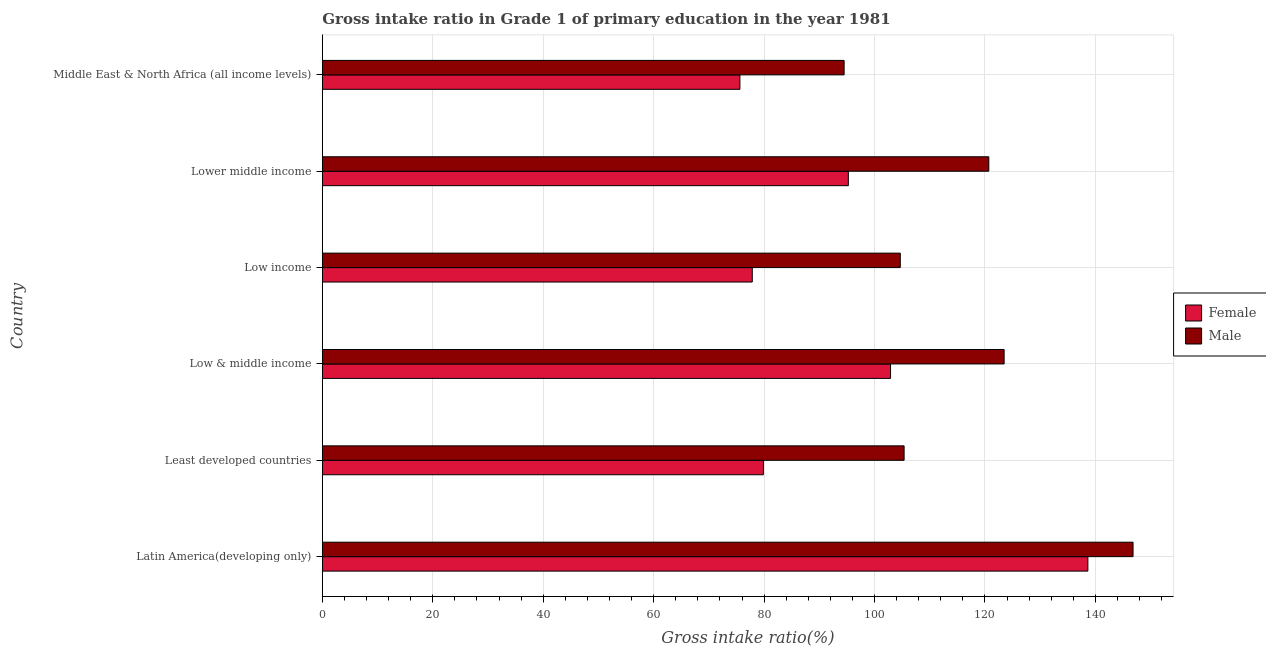Are the number of bars on each tick of the Y-axis equal?
Keep it short and to the point. Yes. How many bars are there on the 6th tick from the bottom?
Provide a short and direct response. 2. What is the label of the 4th group of bars from the top?
Your answer should be compact. Low & middle income. What is the gross intake ratio(male) in Lower middle income?
Provide a succinct answer. 120.7. Across all countries, what is the maximum gross intake ratio(male)?
Provide a short and direct response. 146.82. Across all countries, what is the minimum gross intake ratio(female)?
Provide a succinct answer. 75.62. In which country was the gross intake ratio(male) maximum?
Make the answer very short. Latin America(developing only). In which country was the gross intake ratio(female) minimum?
Make the answer very short. Middle East & North Africa (all income levels). What is the total gross intake ratio(female) in the graph?
Offer a very short reply. 570.16. What is the difference between the gross intake ratio(female) in Latin America(developing only) and that in Low & middle income?
Make the answer very short. 35.73. What is the difference between the gross intake ratio(male) in Middle East & North Africa (all income levels) and the gross intake ratio(female) in Low income?
Keep it short and to the point. 16.63. What is the average gross intake ratio(male) per country?
Your response must be concise. 115.92. What is the difference between the gross intake ratio(male) and gross intake ratio(female) in Lower middle income?
Your response must be concise. 25.44. What is the ratio of the gross intake ratio(male) in Low & middle income to that in Low income?
Your answer should be compact. 1.18. Is the gross intake ratio(male) in Latin America(developing only) less than that in Lower middle income?
Offer a terse response. No. Is the difference between the gross intake ratio(male) in Least developed countries and Low & middle income greater than the difference between the gross intake ratio(female) in Least developed countries and Low & middle income?
Give a very brief answer. Yes. What is the difference between the highest and the second highest gross intake ratio(female)?
Offer a terse response. 35.73. What is the difference between the highest and the lowest gross intake ratio(female)?
Provide a short and direct response. 63.02. In how many countries, is the gross intake ratio(male) greater than the average gross intake ratio(male) taken over all countries?
Offer a terse response. 3. Is the sum of the gross intake ratio(male) in Latin America(developing only) and Least developed countries greater than the maximum gross intake ratio(female) across all countries?
Make the answer very short. Yes. How many bars are there?
Your response must be concise. 12. How many countries are there in the graph?
Keep it short and to the point. 6. What is the difference between two consecutive major ticks on the X-axis?
Keep it short and to the point. 20. Are the values on the major ticks of X-axis written in scientific E-notation?
Offer a very short reply. No. Does the graph contain any zero values?
Give a very brief answer. No. Does the graph contain grids?
Your answer should be compact. Yes. How many legend labels are there?
Your answer should be compact. 2. What is the title of the graph?
Your answer should be very brief. Gross intake ratio in Grade 1 of primary education in the year 1981. Does "Research and Development" appear as one of the legend labels in the graph?
Provide a short and direct response. No. What is the label or title of the X-axis?
Your answer should be compact. Gross intake ratio(%). What is the Gross intake ratio(%) of Female in Latin America(developing only)?
Your answer should be very brief. 138.64. What is the Gross intake ratio(%) in Male in Latin America(developing only)?
Your response must be concise. 146.82. What is the Gross intake ratio(%) of Female in Least developed countries?
Your answer should be very brief. 79.88. What is the Gross intake ratio(%) of Male in Least developed countries?
Give a very brief answer. 105.36. What is the Gross intake ratio(%) in Female in Low & middle income?
Provide a short and direct response. 102.9. What is the Gross intake ratio(%) of Male in Low & middle income?
Give a very brief answer. 123.47. What is the Gross intake ratio(%) in Female in Low income?
Provide a short and direct response. 77.86. What is the Gross intake ratio(%) of Male in Low income?
Keep it short and to the point. 104.66. What is the Gross intake ratio(%) in Female in Lower middle income?
Offer a very short reply. 95.26. What is the Gross intake ratio(%) in Male in Lower middle income?
Your answer should be very brief. 120.7. What is the Gross intake ratio(%) in Female in Middle East & North Africa (all income levels)?
Offer a very short reply. 75.62. What is the Gross intake ratio(%) in Male in Middle East & North Africa (all income levels)?
Offer a terse response. 94.49. Across all countries, what is the maximum Gross intake ratio(%) of Female?
Make the answer very short. 138.64. Across all countries, what is the maximum Gross intake ratio(%) in Male?
Your response must be concise. 146.82. Across all countries, what is the minimum Gross intake ratio(%) in Female?
Give a very brief answer. 75.62. Across all countries, what is the minimum Gross intake ratio(%) of Male?
Keep it short and to the point. 94.49. What is the total Gross intake ratio(%) of Female in the graph?
Ensure brevity in your answer.  570.16. What is the total Gross intake ratio(%) in Male in the graph?
Ensure brevity in your answer.  695.5. What is the difference between the Gross intake ratio(%) in Female in Latin America(developing only) and that in Least developed countries?
Make the answer very short. 58.76. What is the difference between the Gross intake ratio(%) in Male in Latin America(developing only) and that in Least developed countries?
Provide a short and direct response. 41.46. What is the difference between the Gross intake ratio(%) in Female in Latin America(developing only) and that in Low & middle income?
Ensure brevity in your answer.  35.73. What is the difference between the Gross intake ratio(%) in Male in Latin America(developing only) and that in Low & middle income?
Provide a succinct answer. 23.35. What is the difference between the Gross intake ratio(%) in Female in Latin America(developing only) and that in Low income?
Your answer should be compact. 60.78. What is the difference between the Gross intake ratio(%) of Male in Latin America(developing only) and that in Low income?
Give a very brief answer. 42.15. What is the difference between the Gross intake ratio(%) in Female in Latin America(developing only) and that in Lower middle income?
Provide a succinct answer. 43.38. What is the difference between the Gross intake ratio(%) of Male in Latin America(developing only) and that in Lower middle income?
Make the answer very short. 26.12. What is the difference between the Gross intake ratio(%) in Female in Latin America(developing only) and that in Middle East & North Africa (all income levels)?
Offer a terse response. 63.02. What is the difference between the Gross intake ratio(%) in Male in Latin America(developing only) and that in Middle East & North Africa (all income levels)?
Provide a succinct answer. 52.33. What is the difference between the Gross intake ratio(%) in Female in Least developed countries and that in Low & middle income?
Provide a short and direct response. -23.03. What is the difference between the Gross intake ratio(%) of Male in Least developed countries and that in Low & middle income?
Offer a terse response. -18.11. What is the difference between the Gross intake ratio(%) in Female in Least developed countries and that in Low income?
Provide a succinct answer. 2.01. What is the difference between the Gross intake ratio(%) in Male in Least developed countries and that in Low income?
Provide a short and direct response. 0.69. What is the difference between the Gross intake ratio(%) of Female in Least developed countries and that in Lower middle income?
Offer a very short reply. -15.38. What is the difference between the Gross intake ratio(%) of Male in Least developed countries and that in Lower middle income?
Your answer should be compact. -15.34. What is the difference between the Gross intake ratio(%) of Female in Least developed countries and that in Middle East & North Africa (all income levels)?
Offer a terse response. 4.25. What is the difference between the Gross intake ratio(%) of Male in Least developed countries and that in Middle East & North Africa (all income levels)?
Make the answer very short. 10.86. What is the difference between the Gross intake ratio(%) in Female in Low & middle income and that in Low income?
Offer a terse response. 25.04. What is the difference between the Gross intake ratio(%) in Male in Low & middle income and that in Low income?
Offer a very short reply. 18.81. What is the difference between the Gross intake ratio(%) of Female in Low & middle income and that in Lower middle income?
Keep it short and to the point. 7.65. What is the difference between the Gross intake ratio(%) of Male in Low & middle income and that in Lower middle income?
Offer a terse response. 2.77. What is the difference between the Gross intake ratio(%) of Female in Low & middle income and that in Middle East & North Africa (all income levels)?
Keep it short and to the point. 27.28. What is the difference between the Gross intake ratio(%) of Male in Low & middle income and that in Middle East & North Africa (all income levels)?
Your answer should be compact. 28.98. What is the difference between the Gross intake ratio(%) in Female in Low income and that in Lower middle income?
Give a very brief answer. -17.4. What is the difference between the Gross intake ratio(%) in Male in Low income and that in Lower middle income?
Your answer should be compact. -16.03. What is the difference between the Gross intake ratio(%) of Female in Low income and that in Middle East & North Africa (all income levels)?
Give a very brief answer. 2.24. What is the difference between the Gross intake ratio(%) in Male in Low income and that in Middle East & North Africa (all income levels)?
Your response must be concise. 10.17. What is the difference between the Gross intake ratio(%) of Female in Lower middle income and that in Middle East & North Africa (all income levels)?
Ensure brevity in your answer.  19.64. What is the difference between the Gross intake ratio(%) of Male in Lower middle income and that in Middle East & North Africa (all income levels)?
Keep it short and to the point. 26.2. What is the difference between the Gross intake ratio(%) of Female in Latin America(developing only) and the Gross intake ratio(%) of Male in Least developed countries?
Provide a short and direct response. 33.28. What is the difference between the Gross intake ratio(%) in Female in Latin America(developing only) and the Gross intake ratio(%) in Male in Low & middle income?
Offer a terse response. 15.17. What is the difference between the Gross intake ratio(%) in Female in Latin America(developing only) and the Gross intake ratio(%) in Male in Low income?
Provide a short and direct response. 33.97. What is the difference between the Gross intake ratio(%) in Female in Latin America(developing only) and the Gross intake ratio(%) in Male in Lower middle income?
Your answer should be very brief. 17.94. What is the difference between the Gross intake ratio(%) in Female in Latin America(developing only) and the Gross intake ratio(%) in Male in Middle East & North Africa (all income levels)?
Provide a succinct answer. 44.15. What is the difference between the Gross intake ratio(%) of Female in Least developed countries and the Gross intake ratio(%) of Male in Low & middle income?
Ensure brevity in your answer.  -43.59. What is the difference between the Gross intake ratio(%) of Female in Least developed countries and the Gross intake ratio(%) of Male in Low income?
Provide a succinct answer. -24.79. What is the difference between the Gross intake ratio(%) of Female in Least developed countries and the Gross intake ratio(%) of Male in Lower middle income?
Give a very brief answer. -40.82. What is the difference between the Gross intake ratio(%) in Female in Least developed countries and the Gross intake ratio(%) in Male in Middle East & North Africa (all income levels)?
Make the answer very short. -14.62. What is the difference between the Gross intake ratio(%) of Female in Low & middle income and the Gross intake ratio(%) of Male in Low income?
Provide a succinct answer. -1.76. What is the difference between the Gross intake ratio(%) of Female in Low & middle income and the Gross intake ratio(%) of Male in Lower middle income?
Offer a terse response. -17.79. What is the difference between the Gross intake ratio(%) in Female in Low & middle income and the Gross intake ratio(%) in Male in Middle East & North Africa (all income levels)?
Make the answer very short. 8.41. What is the difference between the Gross intake ratio(%) of Female in Low income and the Gross intake ratio(%) of Male in Lower middle income?
Provide a short and direct response. -42.83. What is the difference between the Gross intake ratio(%) of Female in Low income and the Gross intake ratio(%) of Male in Middle East & North Africa (all income levels)?
Keep it short and to the point. -16.63. What is the difference between the Gross intake ratio(%) in Female in Lower middle income and the Gross intake ratio(%) in Male in Middle East & North Africa (all income levels)?
Make the answer very short. 0.77. What is the average Gross intake ratio(%) of Female per country?
Your response must be concise. 95.03. What is the average Gross intake ratio(%) of Male per country?
Offer a very short reply. 115.92. What is the difference between the Gross intake ratio(%) in Female and Gross intake ratio(%) in Male in Latin America(developing only)?
Give a very brief answer. -8.18. What is the difference between the Gross intake ratio(%) in Female and Gross intake ratio(%) in Male in Least developed countries?
Your response must be concise. -25.48. What is the difference between the Gross intake ratio(%) of Female and Gross intake ratio(%) of Male in Low & middle income?
Ensure brevity in your answer.  -20.57. What is the difference between the Gross intake ratio(%) of Female and Gross intake ratio(%) of Male in Low income?
Provide a succinct answer. -26.8. What is the difference between the Gross intake ratio(%) of Female and Gross intake ratio(%) of Male in Lower middle income?
Offer a terse response. -25.44. What is the difference between the Gross intake ratio(%) of Female and Gross intake ratio(%) of Male in Middle East & North Africa (all income levels)?
Your answer should be very brief. -18.87. What is the ratio of the Gross intake ratio(%) of Female in Latin America(developing only) to that in Least developed countries?
Make the answer very short. 1.74. What is the ratio of the Gross intake ratio(%) in Male in Latin America(developing only) to that in Least developed countries?
Ensure brevity in your answer.  1.39. What is the ratio of the Gross intake ratio(%) in Female in Latin America(developing only) to that in Low & middle income?
Provide a short and direct response. 1.35. What is the ratio of the Gross intake ratio(%) of Male in Latin America(developing only) to that in Low & middle income?
Give a very brief answer. 1.19. What is the ratio of the Gross intake ratio(%) in Female in Latin America(developing only) to that in Low income?
Provide a short and direct response. 1.78. What is the ratio of the Gross intake ratio(%) in Male in Latin America(developing only) to that in Low income?
Provide a short and direct response. 1.4. What is the ratio of the Gross intake ratio(%) in Female in Latin America(developing only) to that in Lower middle income?
Give a very brief answer. 1.46. What is the ratio of the Gross intake ratio(%) in Male in Latin America(developing only) to that in Lower middle income?
Provide a short and direct response. 1.22. What is the ratio of the Gross intake ratio(%) of Female in Latin America(developing only) to that in Middle East & North Africa (all income levels)?
Provide a succinct answer. 1.83. What is the ratio of the Gross intake ratio(%) in Male in Latin America(developing only) to that in Middle East & North Africa (all income levels)?
Your answer should be compact. 1.55. What is the ratio of the Gross intake ratio(%) of Female in Least developed countries to that in Low & middle income?
Your answer should be compact. 0.78. What is the ratio of the Gross intake ratio(%) in Male in Least developed countries to that in Low & middle income?
Make the answer very short. 0.85. What is the ratio of the Gross intake ratio(%) in Female in Least developed countries to that in Low income?
Offer a terse response. 1.03. What is the ratio of the Gross intake ratio(%) of Male in Least developed countries to that in Low income?
Make the answer very short. 1.01. What is the ratio of the Gross intake ratio(%) in Female in Least developed countries to that in Lower middle income?
Provide a succinct answer. 0.84. What is the ratio of the Gross intake ratio(%) in Male in Least developed countries to that in Lower middle income?
Your response must be concise. 0.87. What is the ratio of the Gross intake ratio(%) in Female in Least developed countries to that in Middle East & North Africa (all income levels)?
Offer a terse response. 1.06. What is the ratio of the Gross intake ratio(%) of Male in Least developed countries to that in Middle East & North Africa (all income levels)?
Keep it short and to the point. 1.11. What is the ratio of the Gross intake ratio(%) of Female in Low & middle income to that in Low income?
Your response must be concise. 1.32. What is the ratio of the Gross intake ratio(%) of Male in Low & middle income to that in Low income?
Give a very brief answer. 1.18. What is the ratio of the Gross intake ratio(%) in Female in Low & middle income to that in Lower middle income?
Provide a succinct answer. 1.08. What is the ratio of the Gross intake ratio(%) of Male in Low & middle income to that in Lower middle income?
Provide a succinct answer. 1.02. What is the ratio of the Gross intake ratio(%) in Female in Low & middle income to that in Middle East & North Africa (all income levels)?
Your answer should be very brief. 1.36. What is the ratio of the Gross intake ratio(%) in Male in Low & middle income to that in Middle East & North Africa (all income levels)?
Make the answer very short. 1.31. What is the ratio of the Gross intake ratio(%) in Female in Low income to that in Lower middle income?
Your answer should be very brief. 0.82. What is the ratio of the Gross intake ratio(%) of Male in Low income to that in Lower middle income?
Keep it short and to the point. 0.87. What is the ratio of the Gross intake ratio(%) of Female in Low income to that in Middle East & North Africa (all income levels)?
Your answer should be very brief. 1.03. What is the ratio of the Gross intake ratio(%) of Male in Low income to that in Middle East & North Africa (all income levels)?
Ensure brevity in your answer.  1.11. What is the ratio of the Gross intake ratio(%) of Female in Lower middle income to that in Middle East & North Africa (all income levels)?
Make the answer very short. 1.26. What is the ratio of the Gross intake ratio(%) of Male in Lower middle income to that in Middle East & North Africa (all income levels)?
Keep it short and to the point. 1.28. What is the difference between the highest and the second highest Gross intake ratio(%) in Female?
Keep it short and to the point. 35.73. What is the difference between the highest and the second highest Gross intake ratio(%) in Male?
Make the answer very short. 23.35. What is the difference between the highest and the lowest Gross intake ratio(%) in Female?
Make the answer very short. 63.02. What is the difference between the highest and the lowest Gross intake ratio(%) of Male?
Provide a short and direct response. 52.33. 